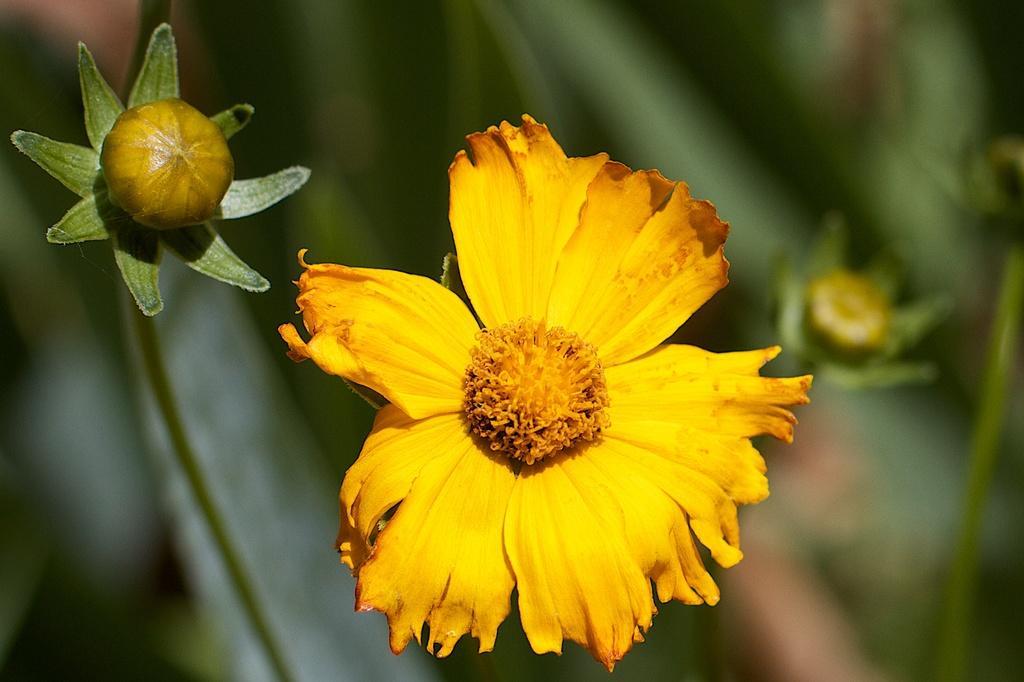How would you summarize this image in a sentence or two? Here we can see yellow flower and flower buds. Background it is blur. 